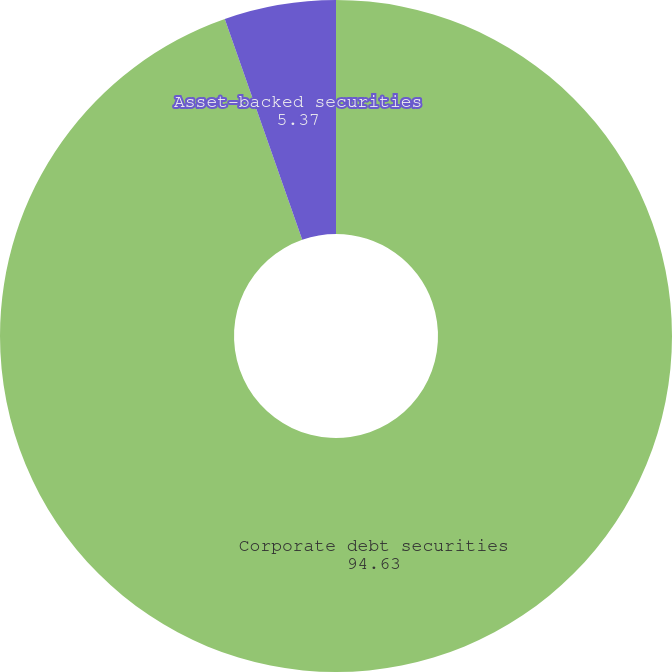Convert chart. <chart><loc_0><loc_0><loc_500><loc_500><pie_chart><fcel>Corporate debt securities<fcel>Asset-backed securities<nl><fcel>94.63%<fcel>5.37%<nl></chart> 